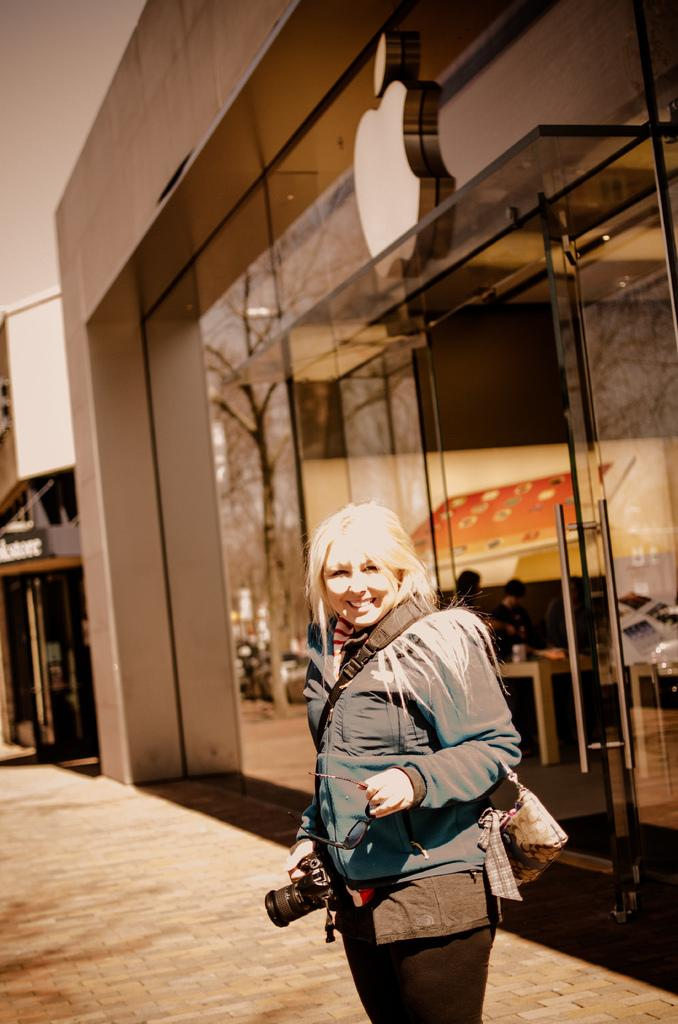Who is present in the image? There is a woman in the image. What is the woman's facial expression? The woman is smiling. What can be seen in the background of the image? There is ground and buildings visible in the background of the image. What type of trouble is the woman experiencing in the image? There is no indication of trouble in the image; the woman is smiling. What type of sofa can be seen in the image? There is no sofa present in the image. 